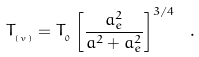<formula> <loc_0><loc_0><loc_500><loc_500>T _ { _ { \left ( v \right ) } } = T _ { _ { 0 } } \left [ \frac { a _ { e } ^ { 2 } } { a ^ { 2 } + a _ { e } ^ { 2 } } \right ] ^ { 3 / 4 } \ .</formula> 